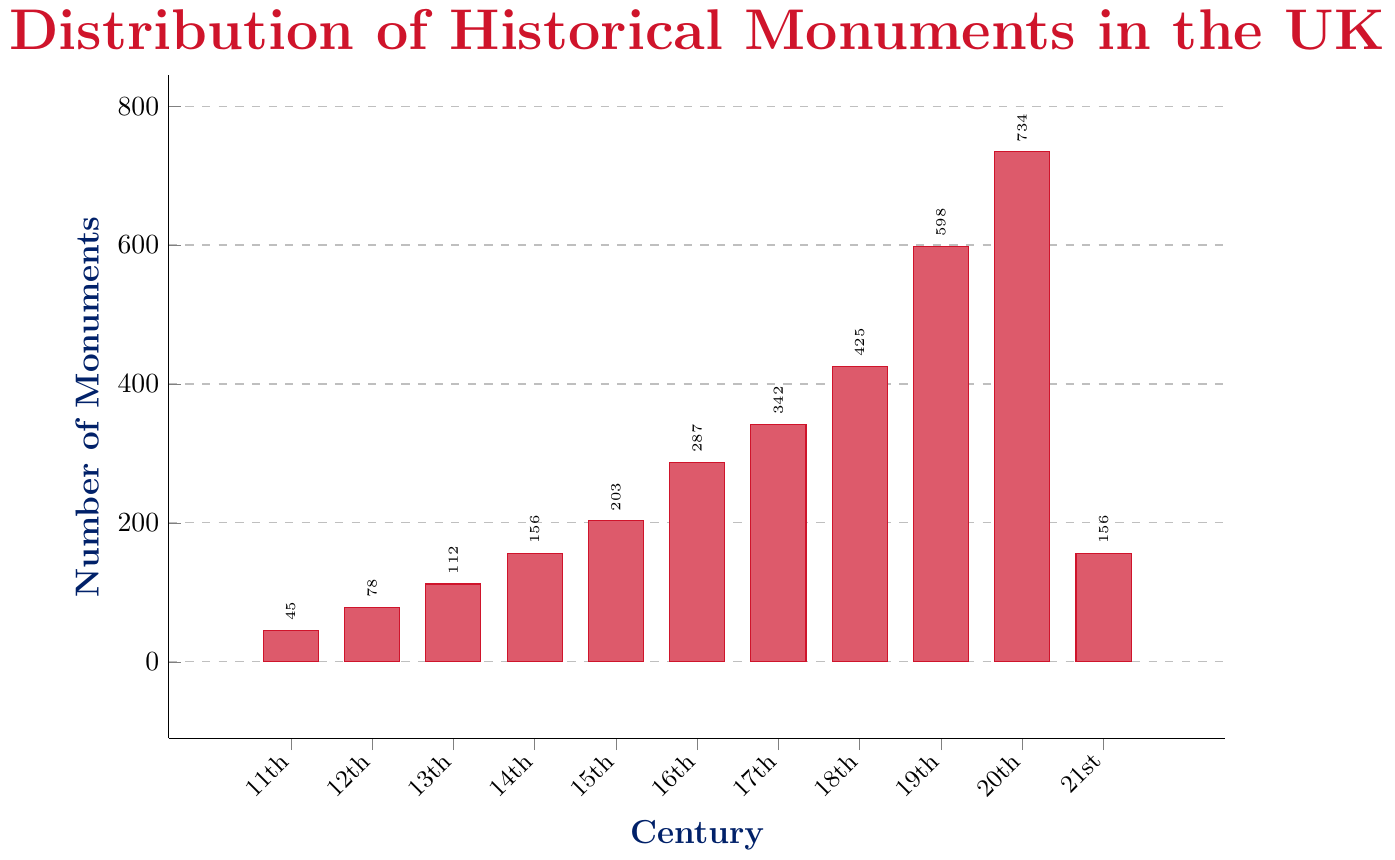Which century has the highest number of historical monuments? The bar for the 20th century is the tallest in the chart, indicating it has the highest number of monuments.
Answer: 20th century Which century has the least number of historical monuments? The bar for the 11th century is the shortest in the chart, indicating it has the fewest monuments.
Answer: 11th century What is the total number of historical monuments constructed from the 16th to the 18th century? Sum the values for the 16th, 17th, and 18th centuries: 287 + 342 + 425 = 1054
Answer: 1054 By how much did the number of monuments in the 20th century exceed those in the 19th century? Subtract the number of monuments in the 19th century from those in the 20th century: 734 - 598 = 136
Answer: 136 What is the average number of monuments constructed per century across all recorded centuries? Sum the number of monuments for all centuries and divide by the number of centuries: (45 + 78 + 112 + 156 + 203 + 287 + 342 + 425 + 598 + 734 + 156) / 11 = 3136 / 11 ≈ 285
Answer: 285 How many more monuments were constructed in the 15th century compared to the 13th century? Subtract the number of monuments in the 13th century from those in the 15th century: 203 - 112 = 91
Answer: 91 What pattern or trend can be observed from the 11th century to the 21st century in terms of monument construction? The bars generally increase in height from the 11th century to the 20th century, indicating more monuments were constructed in later centuries. There is a drop in the 21st century compared to the 20th.
Answer: General increase with a 21st-century drop Which century shows the biggest increase in the number of monuments compared to its previous century? By calculating the difference for each century compared to the previous one, the largest difference occurs between the 18th and 19th centuries: 598 - 425 = 173
Answer: 18th to 19th century How many centuries have less than 200 monuments? The bars for the 11th, 12th, 13th, and 21st centuries are all below 200, totaling four centuries.
Answer: 4 In which century did the number of monuments first exceed 300? The bar for the 17th century is the first that surpasses 300, as it has 342 monuments.
Answer: 17th century 